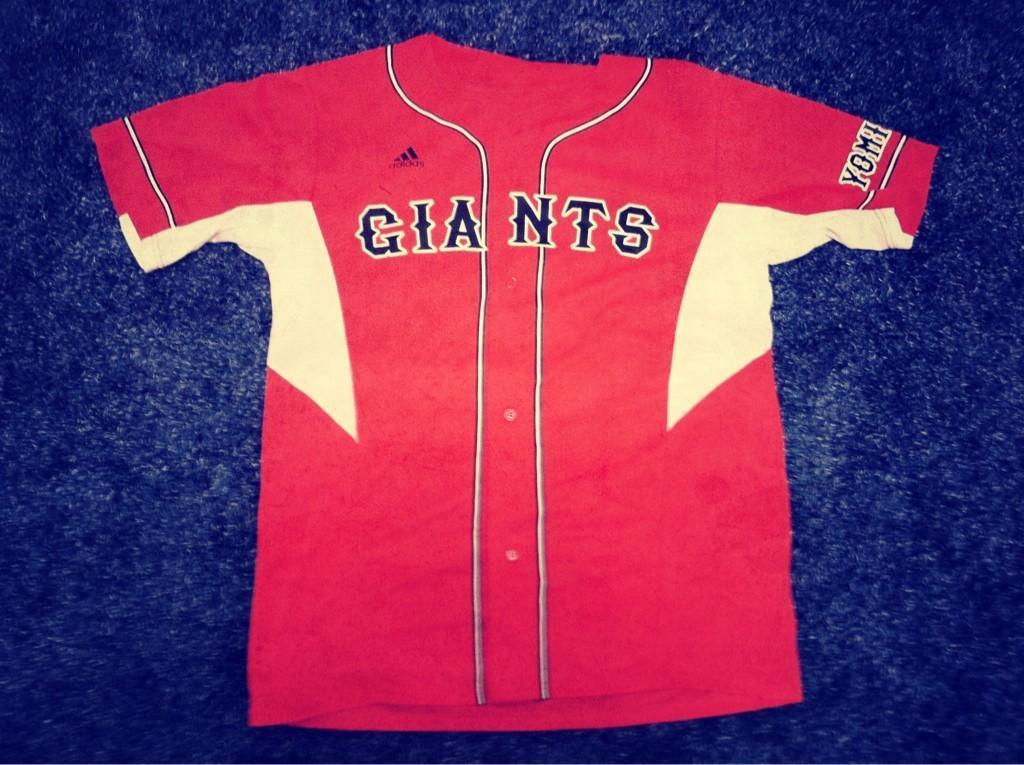<image>
Offer a succinct explanation of the picture presented. A red and white jersey for the Giants baseball team 